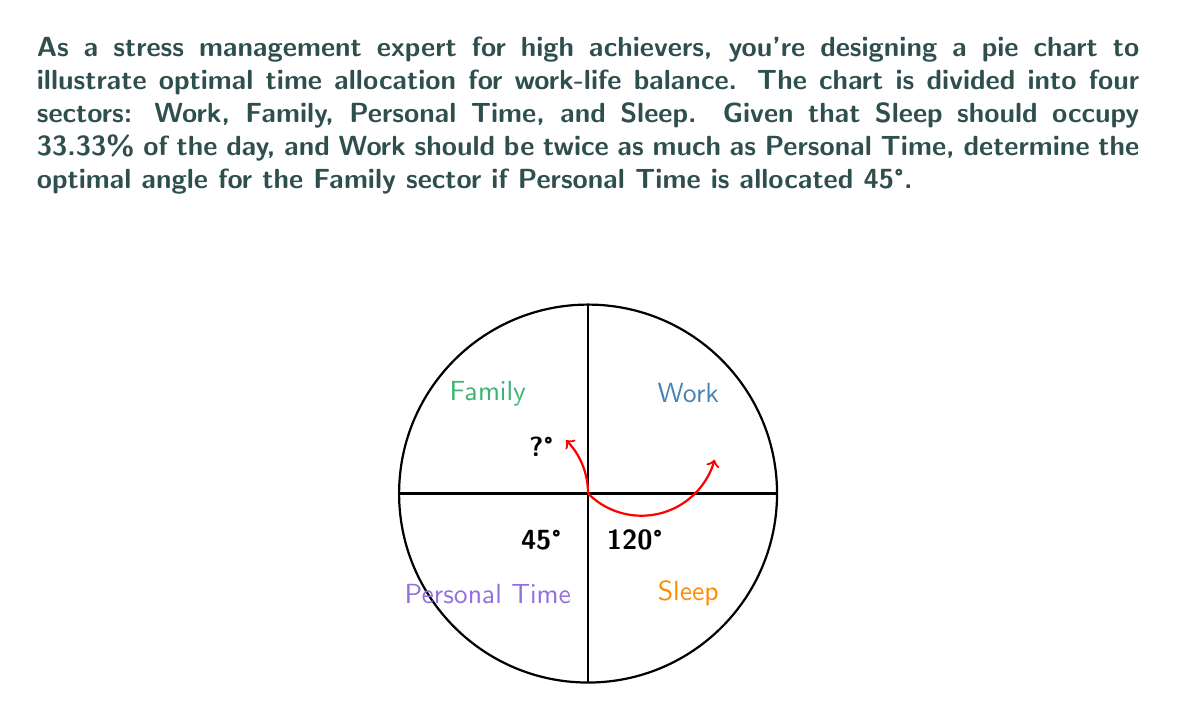Could you help me with this problem? Let's approach this step-by-step:

1) First, let's calculate the angles for the known sectors:
   
   Sleep: $33.33\%$ of 360° = $0.3333 \times 360° = 120°$
   Personal Time: Given as 45°

2) Work is twice Personal Time:
   Work = $2 \times 45° = 90°$

3) Now, let's sum up the angles we know:
   $120° + 45° + 90° = 255°$

4) The total of all sectors in a pie chart must be 360°. So, to find the Family sector:
   
   Family = $360° - 255° = 105°$

5) To verify:
   $120° + 45° + 90° + 105° = 360°$

This distribution ensures that:
- Sleep occupies 33.33% of the day $(120° / 360° = 0.3333)$
- Work is twice Personal Time $(90° / 45° = 2)$
- All sectors sum to a full day $(360°)$
Answer: 105° 